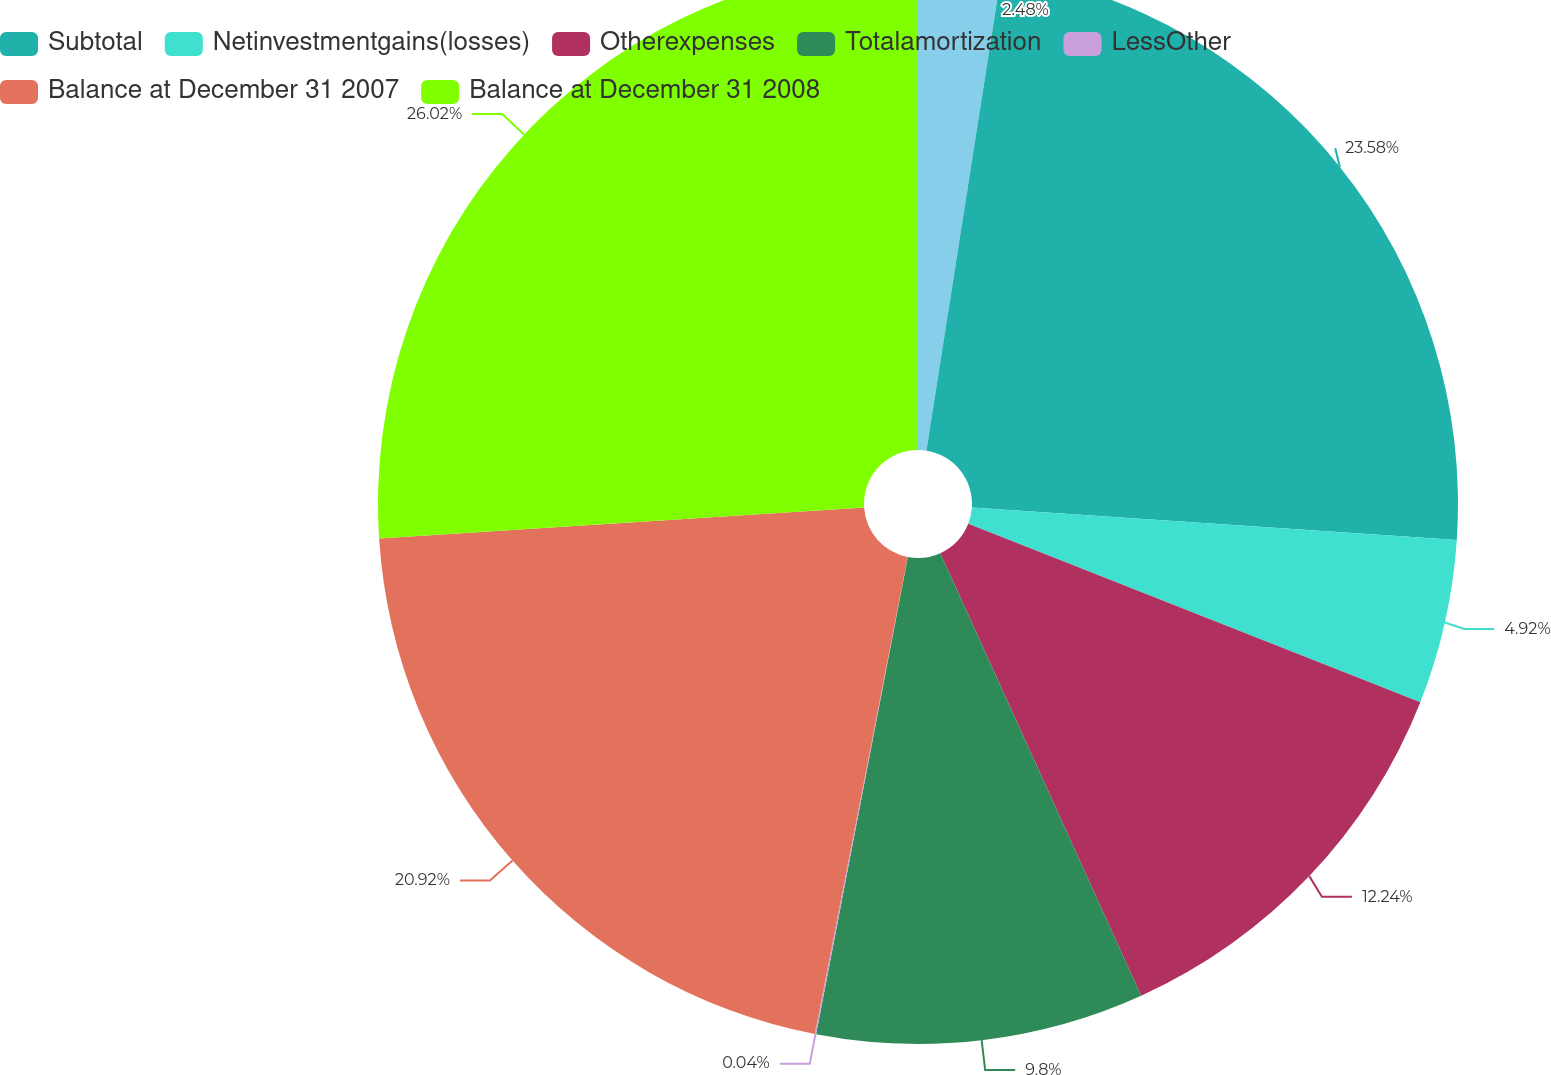Convert chart. <chart><loc_0><loc_0><loc_500><loc_500><pie_chart><ecel><fcel>Subtotal<fcel>Netinvestmentgains(losses)<fcel>Otherexpenses<fcel>Totalamortization<fcel>LessOther<fcel>Balance at December 31 2007<fcel>Balance at December 31 2008<nl><fcel>2.48%<fcel>23.58%<fcel>4.92%<fcel>12.24%<fcel>9.8%<fcel>0.04%<fcel>20.92%<fcel>26.02%<nl></chart> 